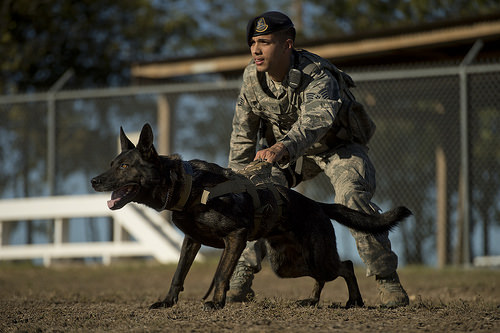<image>
Can you confirm if the dog is on the ground? Yes. Looking at the image, I can see the dog is positioned on top of the ground, with the ground providing support. Where is the dog in relation to the fence? Is it under the fence? No. The dog is not positioned under the fence. The vertical relationship between these objects is different. Is the man in front of the dog? No. The man is not in front of the dog. The spatial positioning shows a different relationship between these objects. 